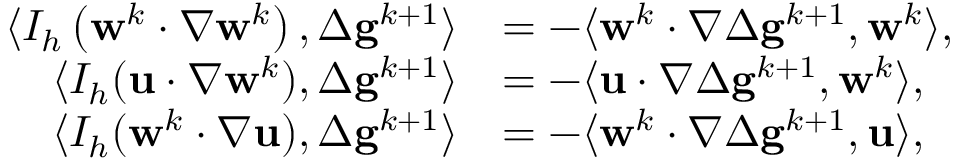<formula> <loc_0><loc_0><loc_500><loc_500>\begin{array} { r l } { \langle I _ { h } \left ( w ^ { k } \cdot \nabla w ^ { k } \right ) , \Delta g ^ { k + 1 } \rangle } & { = - \langle w ^ { k } \cdot \nabla \Delta g ^ { k + 1 } , w ^ { k } \rangle , } \\ { \langle I _ { h } ( u \cdot \nabla w ^ { k } ) , \Delta g ^ { k + 1 } \rangle } & { = - \langle u \cdot \nabla \Delta g ^ { k + 1 } , w ^ { k } \rangle , } \\ { \langle I _ { h } ( w ^ { k } \cdot \nabla u ) , \Delta g ^ { k + 1 } \rangle } & { = - \langle w ^ { k } \cdot \nabla \Delta g ^ { k + 1 } , u \rangle , } \end{array}</formula> 